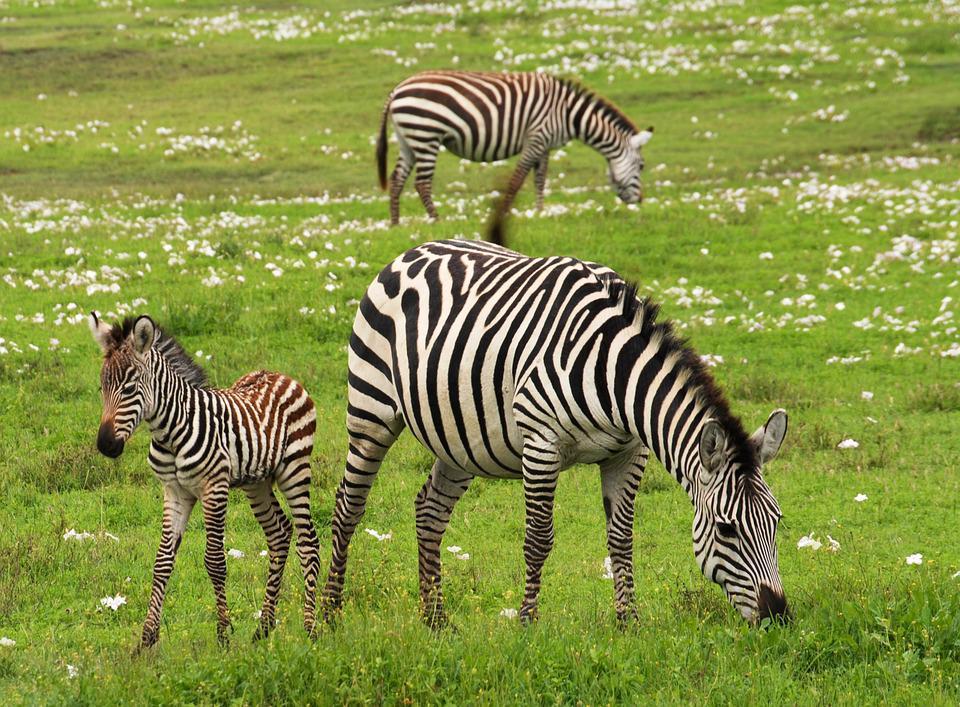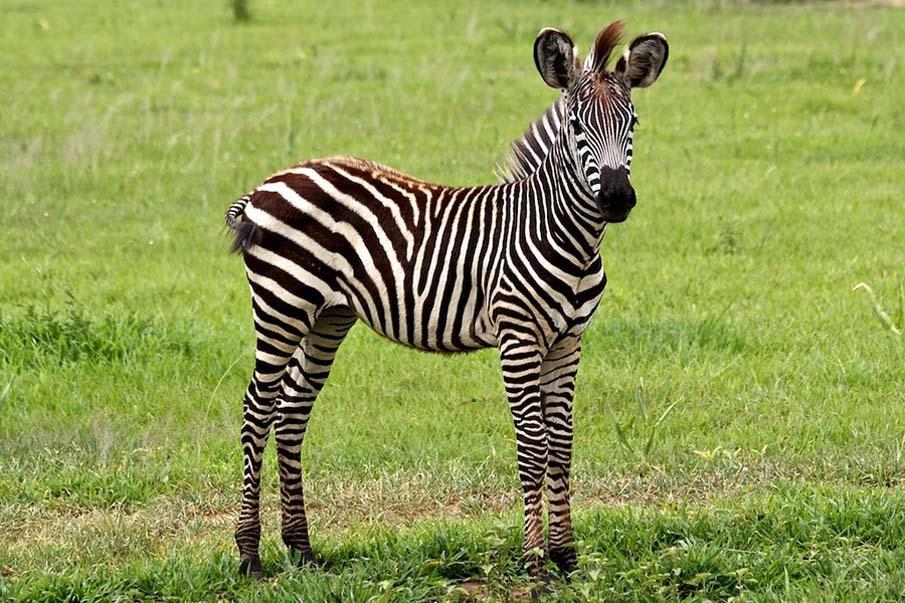The first image is the image on the left, the second image is the image on the right. Examine the images to the left and right. Is the description "The left image contains exactly two zebras." accurate? Answer yes or no. No. The first image is the image on the left, the second image is the image on the right. For the images shown, is this caption "No more than three zebra are shown in total, and the right image contains a single zebra standing with its head and body in profile." true? Answer yes or no. No. 